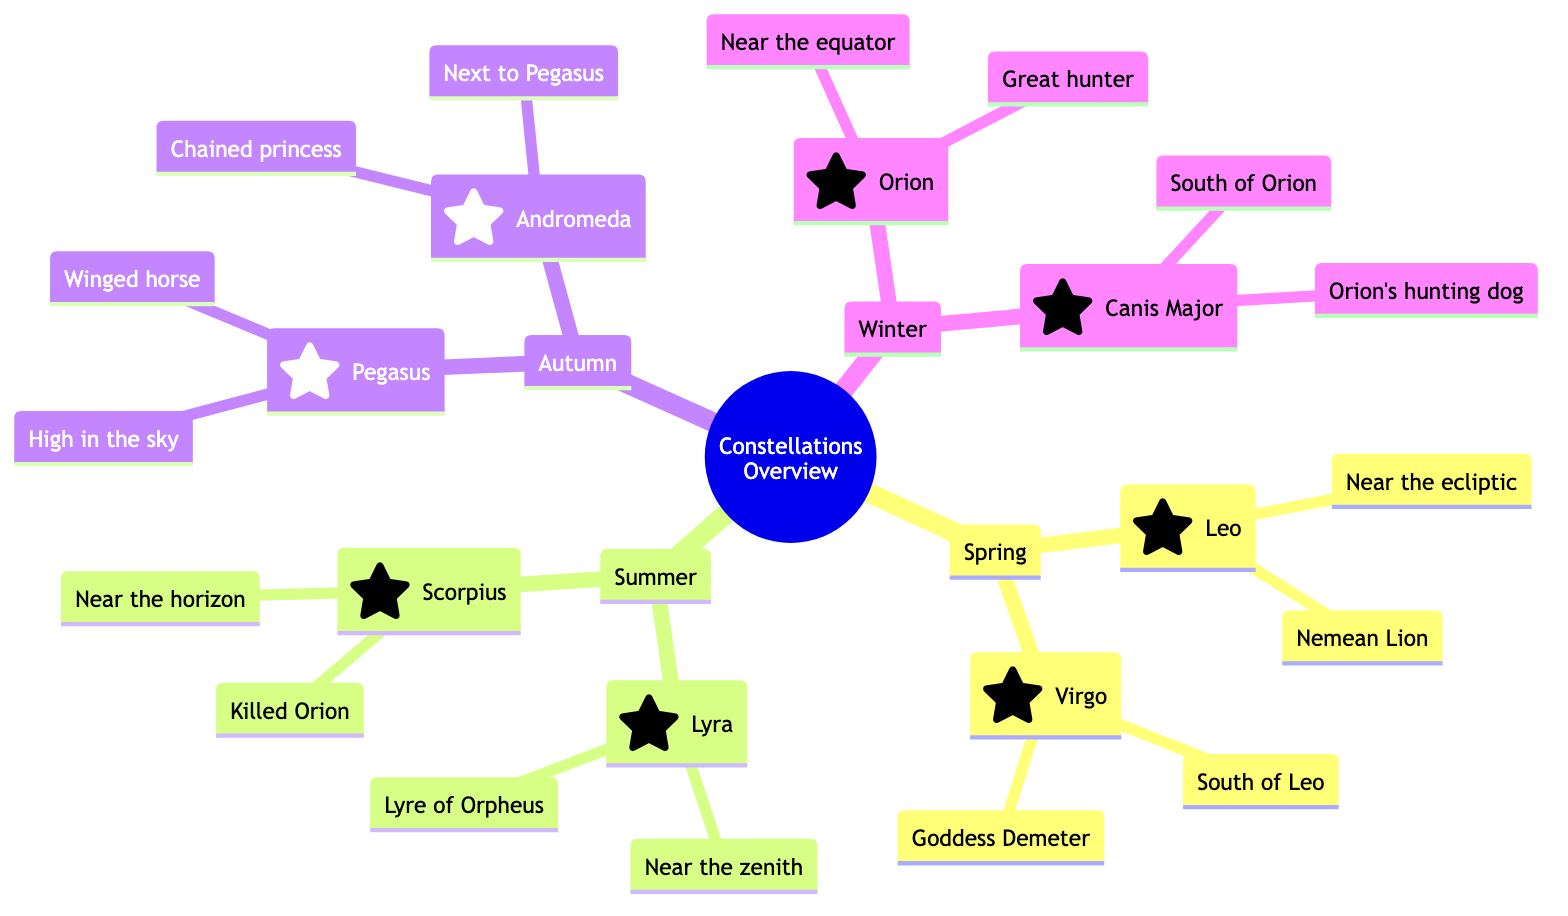What constellations are visible in spring? The diagram indicates that the visible constellations in spring are Leo and Virgo. By examining the Spring section, I can see these two constellations listed directly under the season label.
Answer: Leo, Virgo Which constellation is located near the ecliptic in spring? The specific location of Leo is mentioned in the diagram as "Near the ecliptic" under the spring section. This indicates its position relative to the celestial path that the sun appears to follow.
Answer: Leo How many constellations are shown for autumn? The diagram contains two constellations listed in the Autumn section: Pegasus and Andromeda. Counting them, there are precisely two constellations.
Answer: 2 Which constellation is south of Orion in winter? The diagram lists Canis Major as being "South of Orion" in the winter section. This directional relationship is explicitly mentioned.
Answer: Canis Major What does the constellation Virgo represent? According to the diagram, Virgo is associated with Goddess Demeter, as indicated in the description for that constellation. This answer directly refers to the mythology aspect provided for Virgo.
Answer: Goddess Demeter Which constellation is near the zenith during summer? The diagram states that Lyra is "Near the zenith" in the summer section, thus representing its position high in the sky relative to other constellations.
Answer: Lyra What mythology is associated with Pegasus in autumn? The diagram reveals that Pegasus symbolizes the "Winged horse," which highlights its mythological representation as mentioned in the Autumn section.
Answer: Winged horse Which constellation is responsible for killing Orion according to the summer myth? The diagram identifies Scorpius as the constellation that "Killed Orion," clearly stating its mythological role linked to Orion.
Answer: Scorpius What is the common theme of the constellations listed under winter? In the winter section, two constellations are mentioned: Orion and Canis Major. Both are related to hunting themes—Orion being the "Great hunter" and Canis Major as "Orion's hunting dog". This thematic connection shows a relationship in their mythology.
Answer: Hunting 